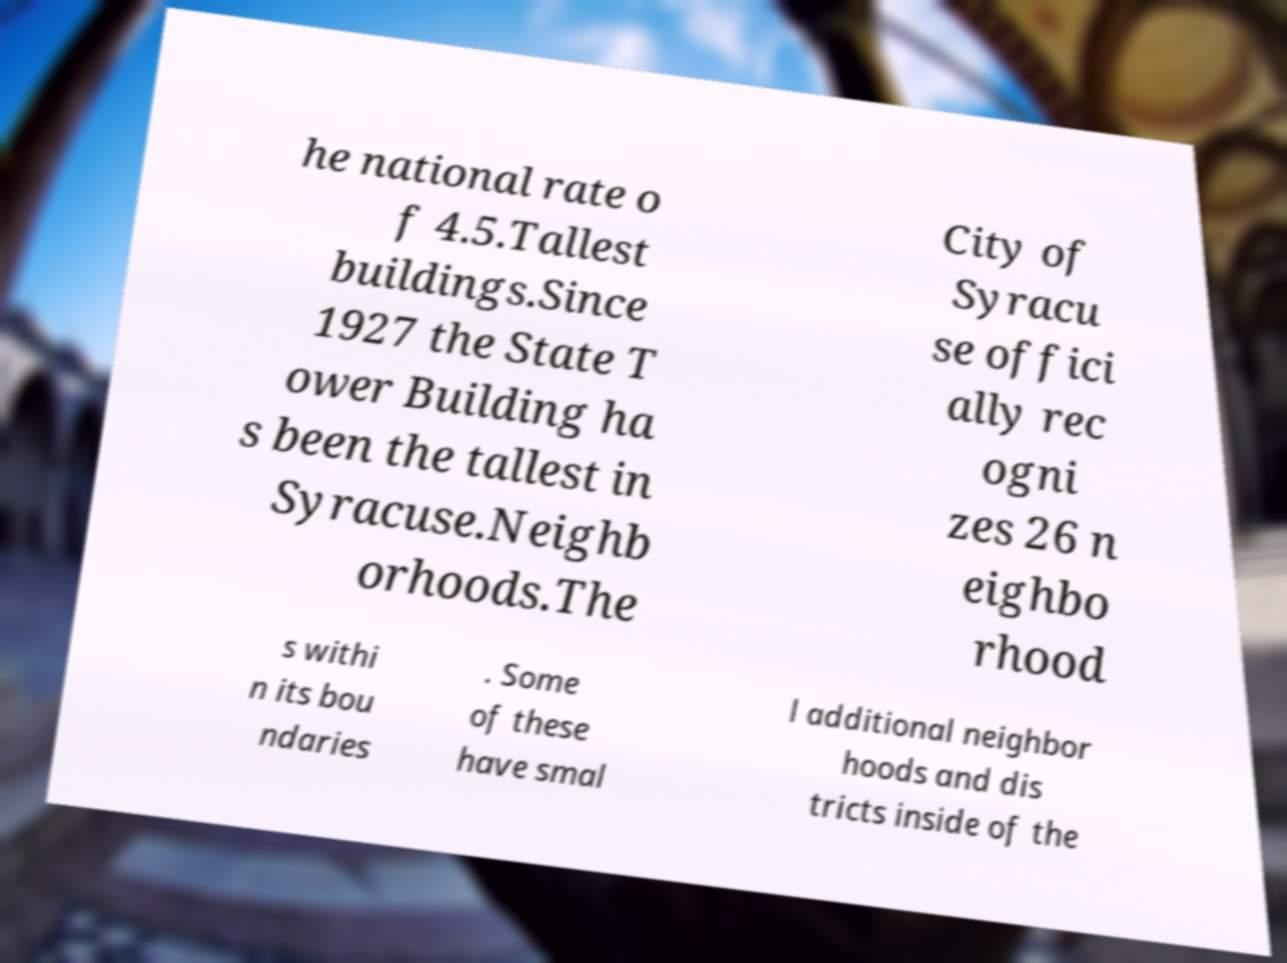Please read and relay the text visible in this image. What does it say? he national rate o f 4.5.Tallest buildings.Since 1927 the State T ower Building ha s been the tallest in Syracuse.Neighb orhoods.The City of Syracu se offici ally rec ogni zes 26 n eighbo rhood s withi n its bou ndaries . Some of these have smal l additional neighbor hoods and dis tricts inside of the 